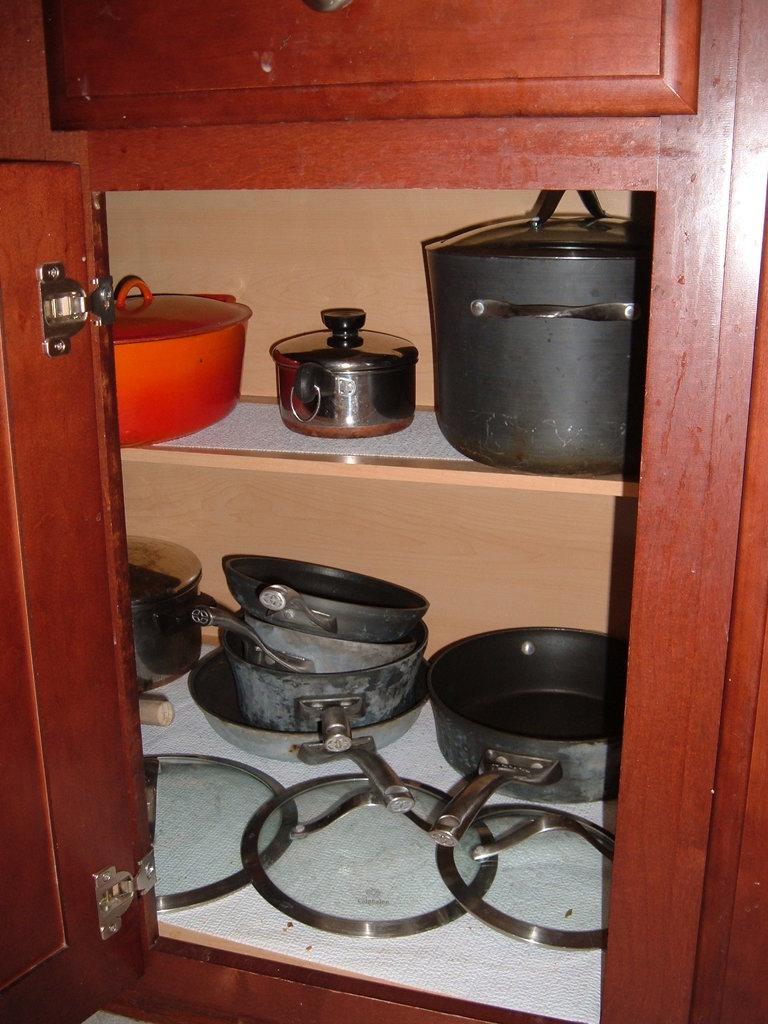Describe this image in one or two sentences. In this image we can see a cupboard. Inside the cupboard we can see pans and some other vessels. 